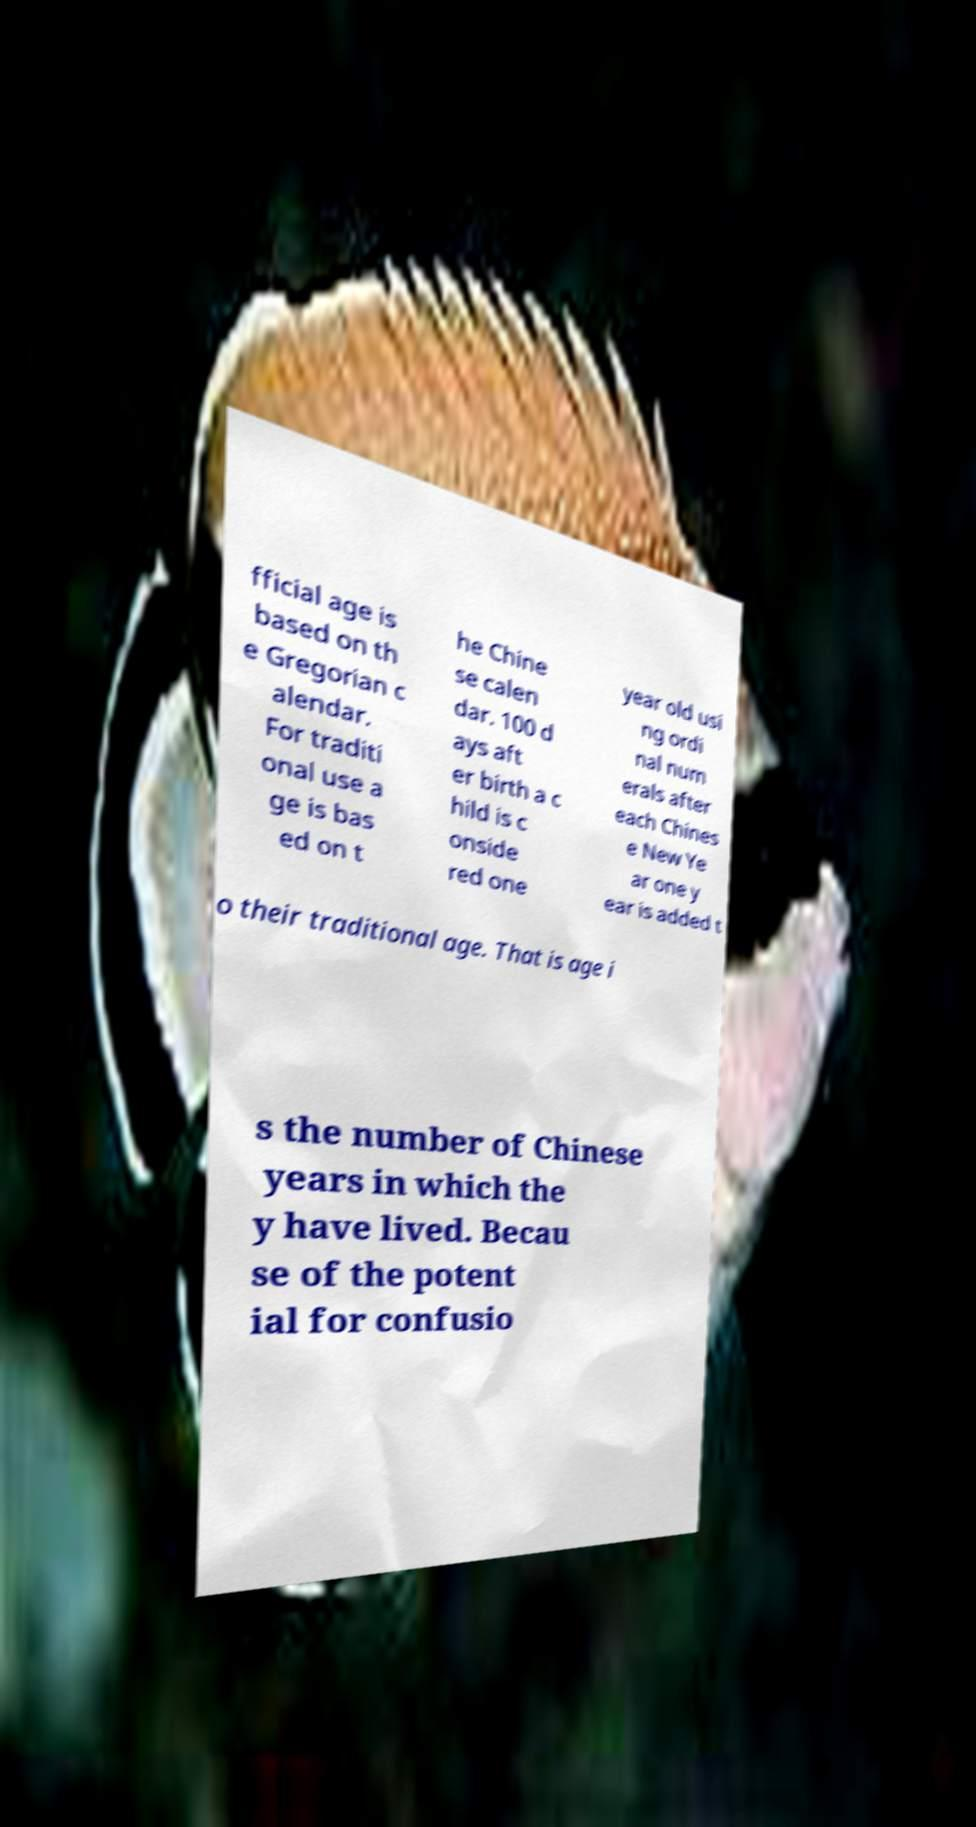Could you extract and type out the text from this image? fficial age is based on th e Gregorian c alendar. For traditi onal use a ge is bas ed on t he Chine se calen dar. 100 d ays aft er birth a c hild is c onside red one year old usi ng ordi nal num erals after each Chines e New Ye ar one y ear is added t o their traditional age. That is age i s the number of Chinese years in which the y have lived. Becau se of the potent ial for confusio 